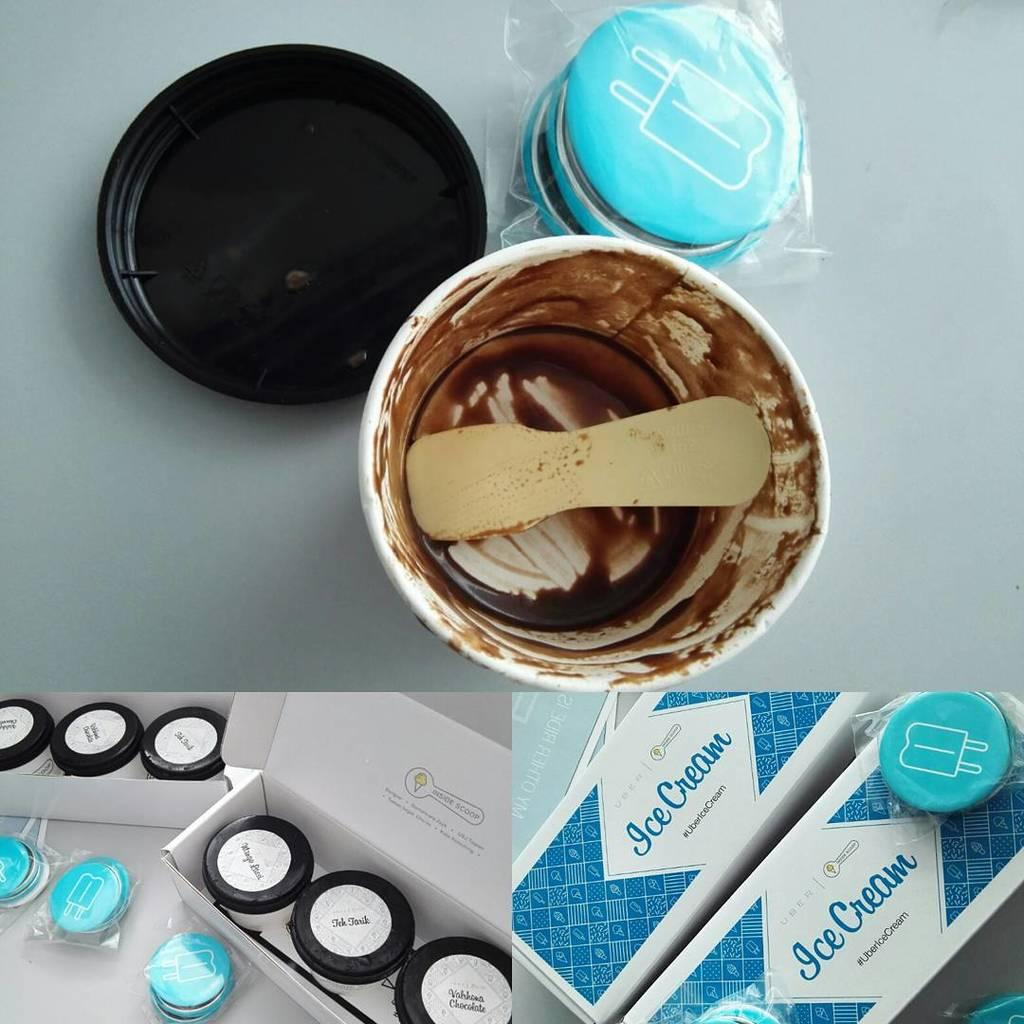Provide a one-sentence caption for the provided image. an image of icecream with an empty tub in the middle. 